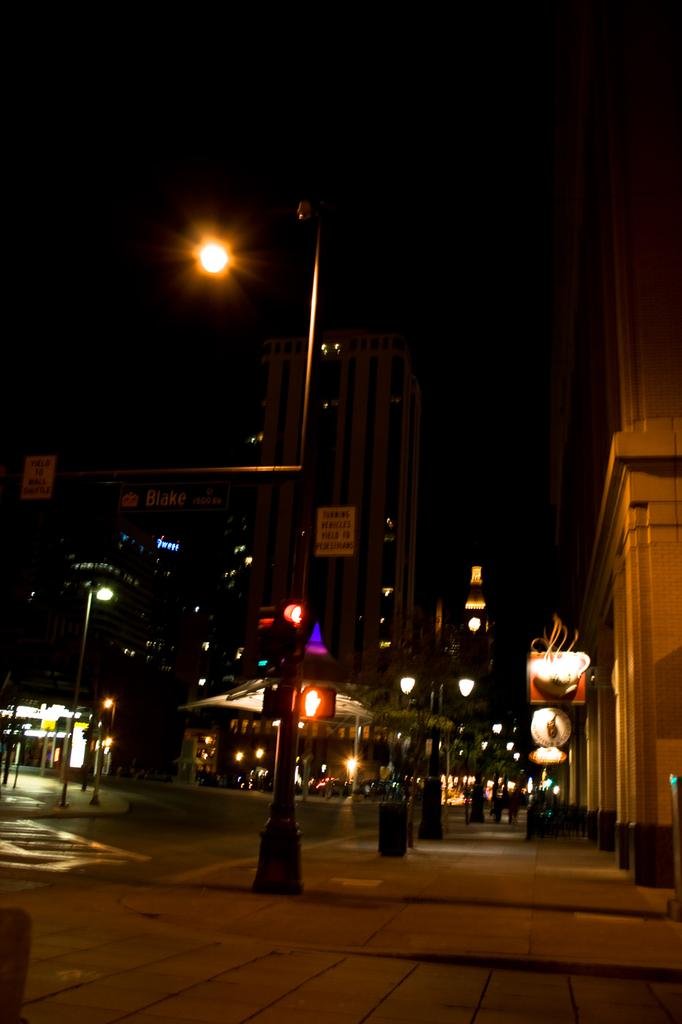What is the main object in the foreground of the image? There is a pole in the image. What is attached to the pole in the image? There is a light attached to the pole in the image. What can be seen in the background of the image? There are buildings, poles, lights, hoardings, and boards in the background of the image. How would you describe the lighting conditions in the image? The background of the image is dark. What type of bells can be heard ringing in the image? There are no bells present in the image, and therefore no sound can be heard. Is there a whip visible in the image? There is no whip present in the image. What kind of hat is worn by the person in the image? There is no person present in the image, so it is not possible to determine if a hat is worn. 